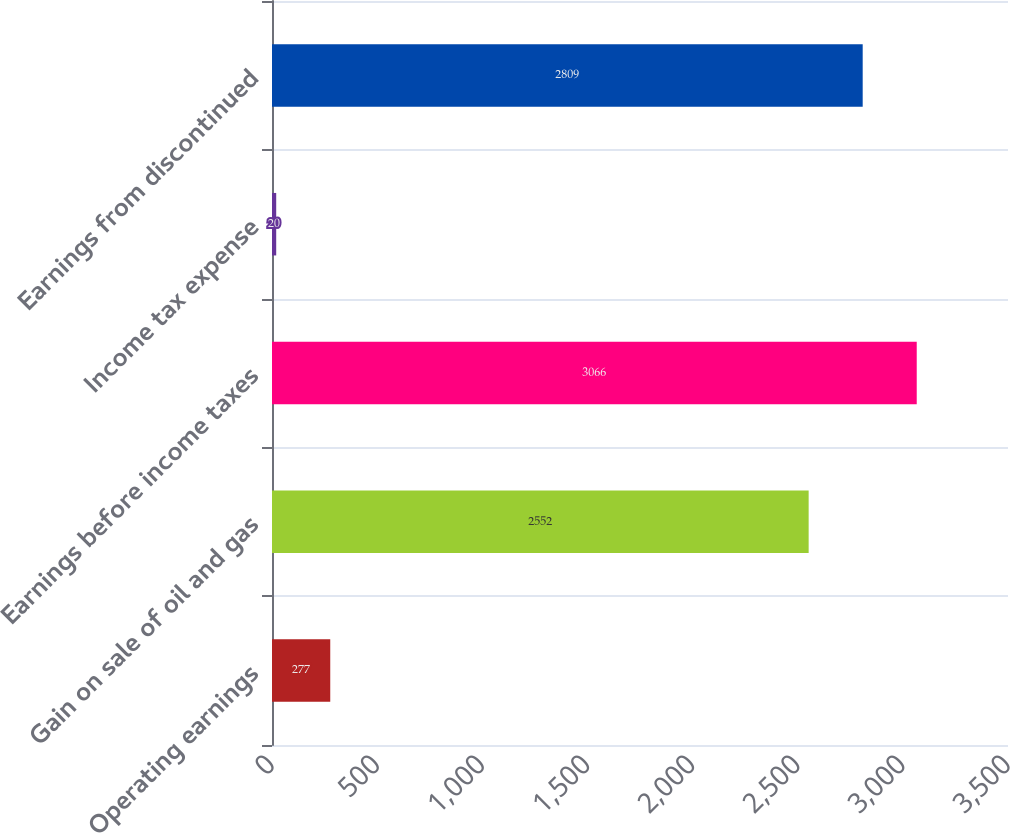Convert chart to OTSL. <chart><loc_0><loc_0><loc_500><loc_500><bar_chart><fcel>Operating earnings<fcel>Gain on sale of oil and gas<fcel>Earnings before income taxes<fcel>Income tax expense<fcel>Earnings from discontinued<nl><fcel>277<fcel>2552<fcel>3066<fcel>20<fcel>2809<nl></chart> 